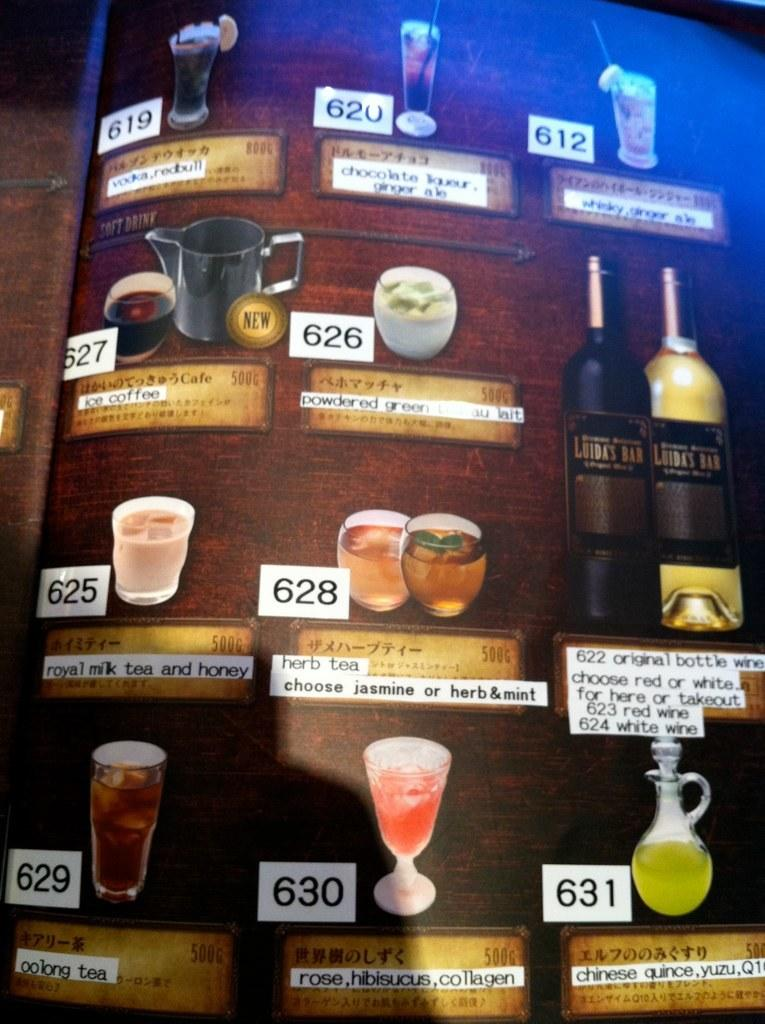<image>
Relay a brief, clear account of the picture shown. Various drinks are shown on a wall, including herb tea and oolong tea. 